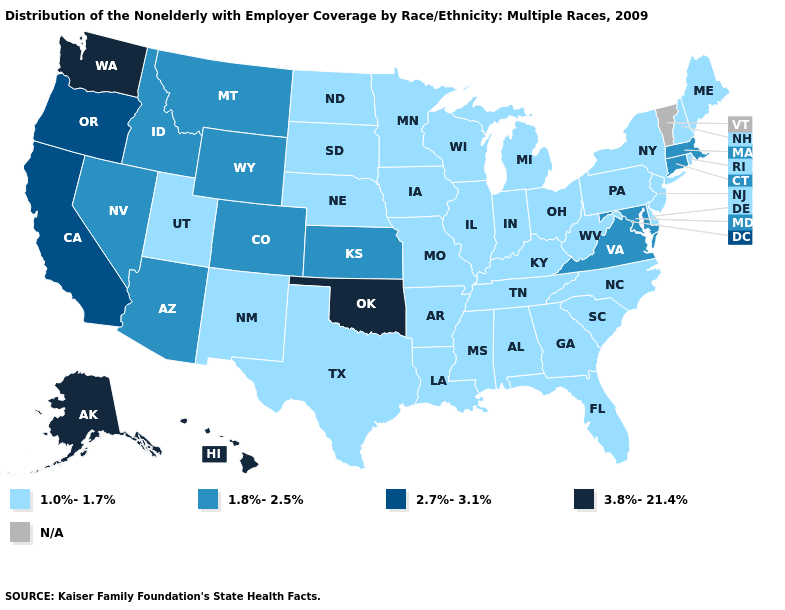What is the lowest value in the West?
Keep it brief. 1.0%-1.7%. What is the value of North Dakota?
Concise answer only. 1.0%-1.7%. Name the states that have a value in the range N/A?
Answer briefly. Vermont. Name the states that have a value in the range 1.0%-1.7%?
Keep it brief. Alabama, Arkansas, Delaware, Florida, Georgia, Illinois, Indiana, Iowa, Kentucky, Louisiana, Maine, Michigan, Minnesota, Mississippi, Missouri, Nebraska, New Hampshire, New Jersey, New Mexico, New York, North Carolina, North Dakota, Ohio, Pennsylvania, Rhode Island, South Carolina, South Dakota, Tennessee, Texas, Utah, West Virginia, Wisconsin. What is the value of Mississippi?
Quick response, please. 1.0%-1.7%. What is the value of Kentucky?
Keep it brief. 1.0%-1.7%. Name the states that have a value in the range 3.8%-21.4%?
Be succinct. Alaska, Hawaii, Oklahoma, Washington. Name the states that have a value in the range 3.8%-21.4%?
Be succinct. Alaska, Hawaii, Oklahoma, Washington. Name the states that have a value in the range 1.8%-2.5%?
Keep it brief. Arizona, Colorado, Connecticut, Idaho, Kansas, Maryland, Massachusetts, Montana, Nevada, Virginia, Wyoming. Among the states that border North Carolina , which have the lowest value?
Short answer required. Georgia, South Carolina, Tennessee. What is the value of Oklahoma?
Write a very short answer. 3.8%-21.4%. Does Hawaii have the highest value in the USA?
Be succinct. Yes. 